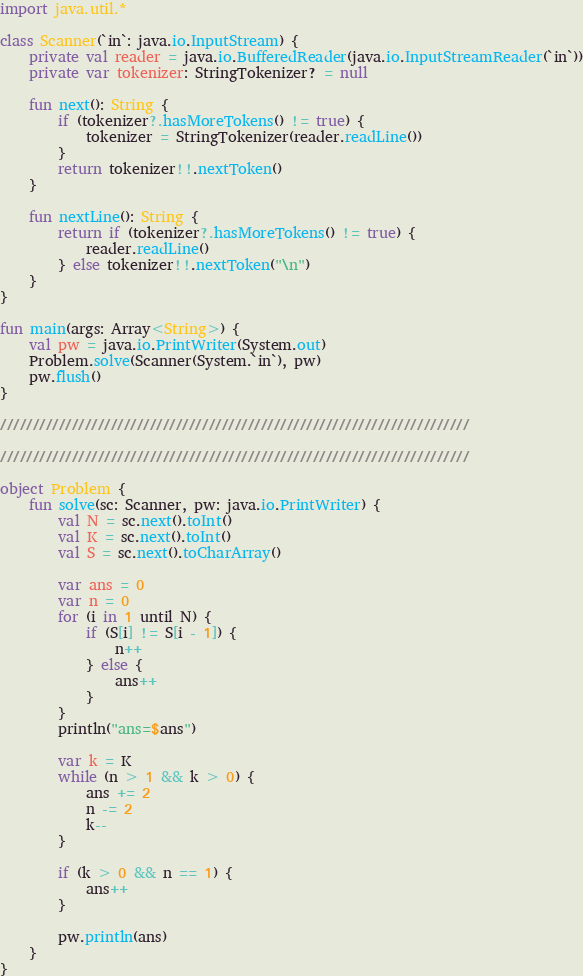Convert code to text. <code><loc_0><loc_0><loc_500><loc_500><_Kotlin_>import java.util.*

class Scanner(`in`: java.io.InputStream) {
    private val reader = java.io.BufferedReader(java.io.InputStreamReader(`in`))
    private var tokenizer: StringTokenizer? = null

    fun next(): String {
        if (tokenizer?.hasMoreTokens() != true) {
            tokenizer = StringTokenizer(reader.readLine())
        }
        return tokenizer!!.nextToken()
    }

    fun nextLine(): String {
        return if (tokenizer?.hasMoreTokens() != true) {
            reader.readLine()
        } else tokenizer!!.nextToken("\n")
    }
}

fun main(args: Array<String>) {
    val pw = java.io.PrintWriter(System.out)
    Problem.solve(Scanner(System.`in`), pw)
    pw.flush()
}

////////////////////////////////////////////////////////////////////////

////////////////////////////////////////////////////////////////////////

object Problem {
    fun solve(sc: Scanner, pw: java.io.PrintWriter) {
        val N = sc.next().toInt()
        val K = sc.next().toInt()
        val S = sc.next().toCharArray()

        var ans = 0
        var n = 0
        for (i in 1 until N) {
            if (S[i] != S[i - 1]) {
                n++
            } else {
                ans++
            }
        }
        println("ans=$ans")

        var k = K
        while (n > 1 && k > 0) {
            ans += 2
            n -= 2
            k--
        }

        if (k > 0 && n == 1) {
            ans++
        }

        pw.println(ans)
    }
}
</code> 